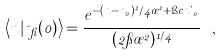<formula> <loc_0><loc_0><loc_500><loc_500>\left < n | \psi _ { \beta } ( 0 ) \right > = \frac { e ^ { - ( n - n _ { 0 } ) ^ { 2 } / 4 \sigma ^ { 2 } + \i c n \theta _ { 0 } } } { ( 2 \pi \sigma ^ { 2 } ) ^ { 1 / 4 } } \ ,</formula> 